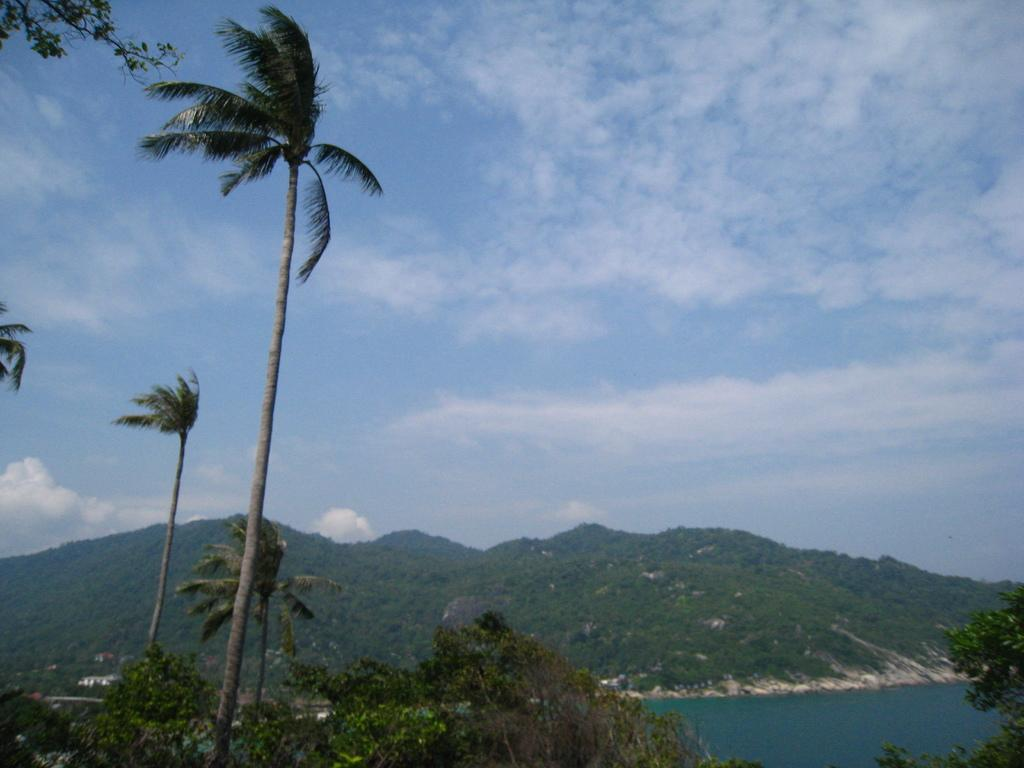What can be seen in the sky in the background of the image? There are clouds in the sky in the background of the image. What type of landscape features are visible in the background of the image? Hills and thicket are visible in the background of the image. What is the body of water visible in the image? There is water visible in the image. What type of vegetation is present in the image? There are trees in the image. Where is the daughter playing in the image? There is no daughter present in the image. What type of motion can be observed in the image? There is no motion visible in the image; it appears to be a still scene. 